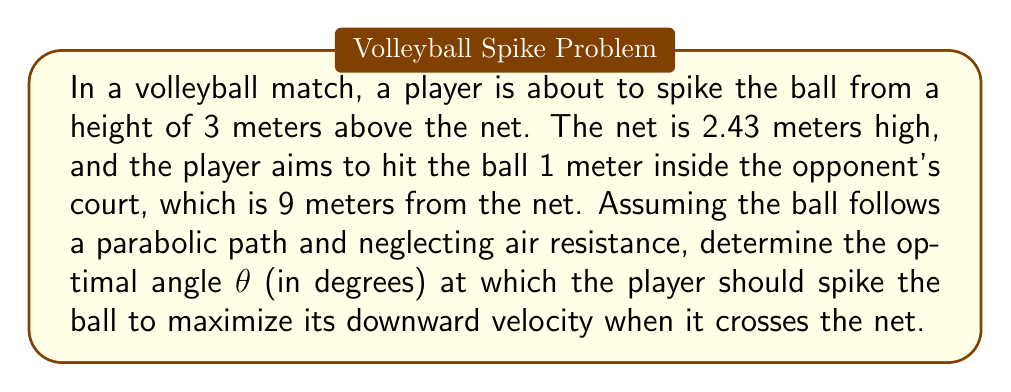Could you help me with this problem? Let's approach this step-by-step using trigonometry and vector analysis:

1) First, let's define our coordinate system. Let the origin be at the base of the net, with the x-axis pointing towards the opponent's court and the y-axis pointing upwards.

2) The initial position of the ball is (0, 3) and the target position is (9, 1).

3) The ball's trajectory can be described by the parametric equations:
   $$x = v_0 \cos(\theta) t$$
   $$y = 3 + v_0 \sin(\theta) t - \frac{1}{2}gt^2$$
   where $v_0$ is the initial velocity, $\theta$ is the angle of spike, $t$ is time, and $g$ is the acceleration due to gravity (9.8 m/s²).

4) We want to maximize the downward velocity when the ball crosses the net. This occurs when $x = 0$ (at the net). The vertical velocity at this point is:
   $$v_y = v_0 \sin(\theta) - gt$$

5) To find $t$ when the ball crosses the net, we use the x-equation:
   $$0 = v_0 \cos(\theta) t$$
   $$t = 0$$

6) Substituting this back into the y-equation:
   $$2.43 = 3 + v_0 \sin(\theta) (0) - \frac{1}{2}g(0)^2$$
   $$2.43 = 3$$

7) This shows that the ball should cross the net at its highest point, where the vertical velocity is zero:
   $$0 = v_0 \sin(\theta) - gt$$
   $$v_0 \sin(\theta) = gt$$

8) Now, using the target point (9, 1), we can set up two equations:
   $$9 = v_0 \cos(\theta) T$$
   $$1 = 3 + v_0 \sin(\theta) T - \frac{1}{2}gT^2$$
   where $T$ is the total time of flight.

9) From step 7, we know that $t = \frac{v_0 \sin(\theta)}{g}$. The total time $T$ is twice this:
   $$T = \frac{2v_0 \sin(\theta)}{g}$$

10) Substituting this into the x-equation from step 8:
    $$9 = v_0 \cos(\theta) \frac{2v_0 \sin(\theta)}{g}$$
    $$9 = \frac{2v_0^2 \sin(\theta) \cos(\theta)}{g}$$
    $$9 = \frac{v_0^2 \sin(2\theta)}{g}$$

11) Now, using the y-equation from step 8 and substituting for $T$:
    $$1 = 3 + v_0 \sin(\theta) \frac{2v_0 \sin(\theta)}{g} - \frac{1}{2}g(\frac{2v_0 \sin(\theta)}{g})^2$$
    $$1 = 3 + \frac{2v_0^2 \sin^2(\theta)}{g} - \frac{2v_0^2 \sin^2(\theta)}{g}$$
    $$1 = 3$$

12) This confirms our earlier finding that the ball should reach its maximum height at the net.

13) From step 10, we can solve for $v_0$:
    $$v_0 = \sqrt{\frac{9g}{\sin(2\theta)}}$$

14) To maximize the downward velocity at the net, we need to maximize $\sin(2\theta)$. This occurs when $2\theta = 90°$, or $\theta = 45°$.

Therefore, the optimal angle for the spike is 45°.
Answer: 45° 